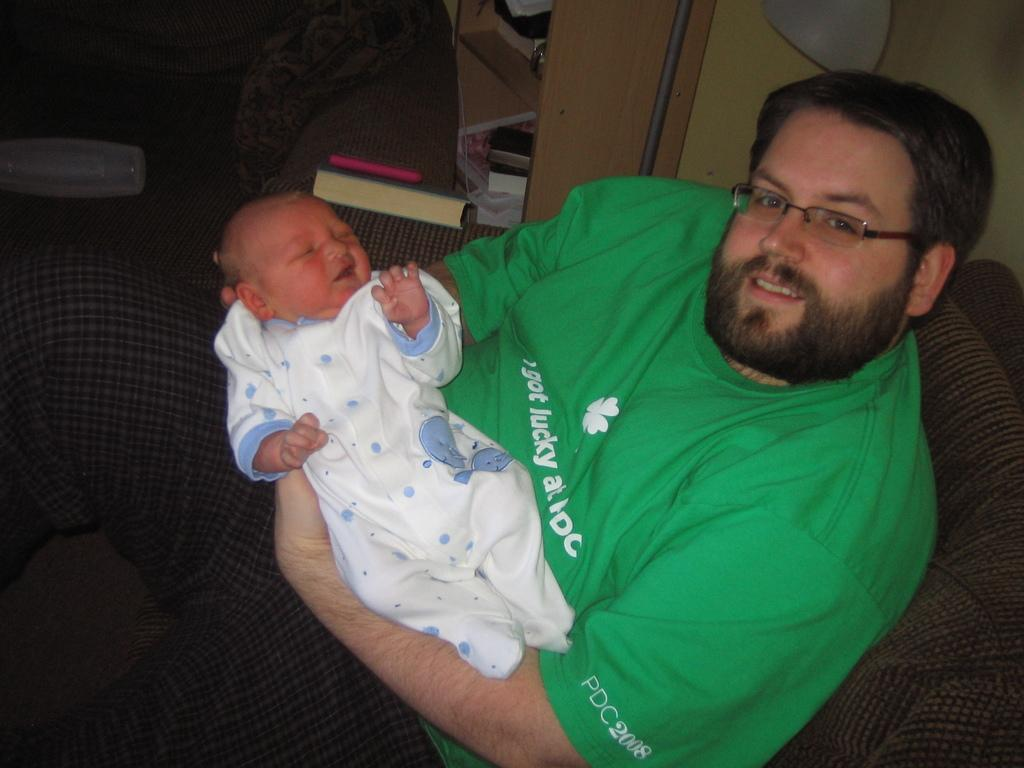Provide a one-sentence caption for the provided image. A man wearing an "I got lucky shirt" holds a baby. 